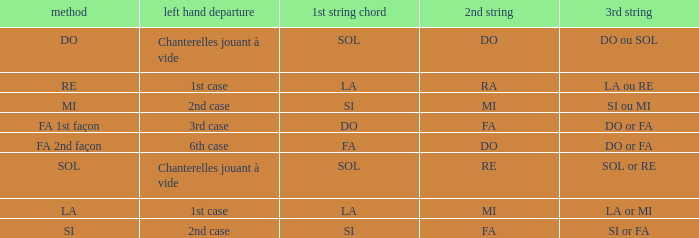For the 2nd string of Do and an Accord du 1st string of FA what is the Depart de la main gauche? 6th case. 